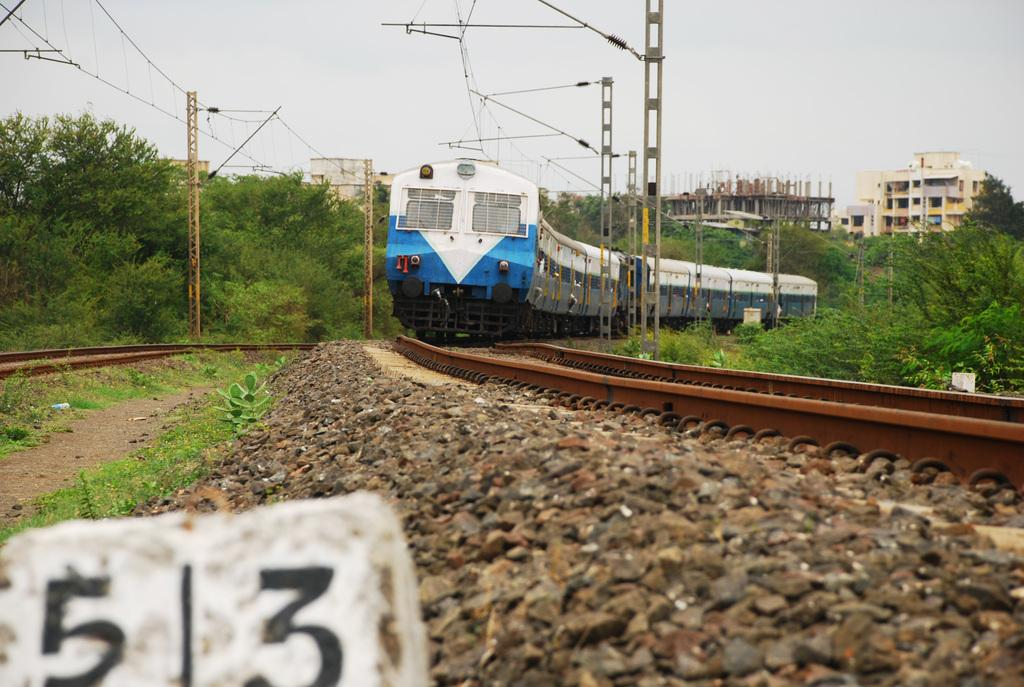<image>
Summarize the visual content of the image. White rock which says 513 in front of a train track. 